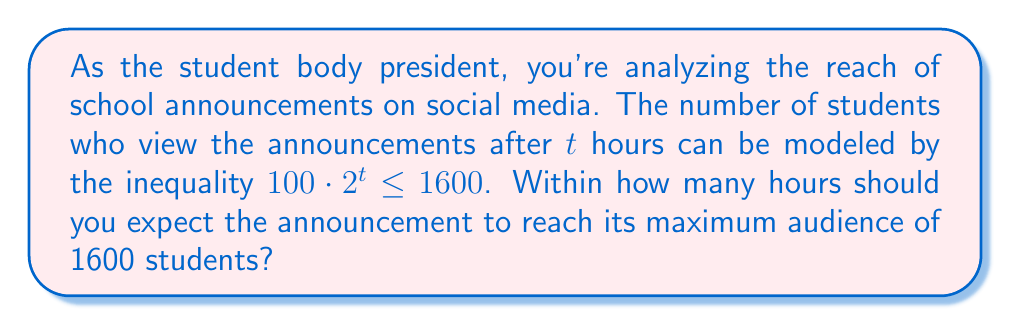Could you help me with this problem? Let's approach this step-by-step:

1) We start with the inequality:
   $100 \cdot 2^t \leq 1600$

2) Divide both sides by 100:
   $2^t \leq 16$

3) To solve for t, we need to take the logarithm (base 2) of both sides:
   $\log_2(2^t) \leq \log_2(16)$

4) The left side simplifies due to the logarithm rule $\log_a(a^x) = x$:
   $t \leq \log_2(16)$

5) We know that $2^4 = 16$, so:
   $t \leq 4$

6) Since t represents time in hours, and we're asked for the number of hours within which the maximum audience is reached, we need the largest integer value of t that satisfies the inequality.

7) The largest integer less than or equal to 4 is 4 itself.

Therefore, you should expect the announcement to reach its maximum audience within 4 hours.
Answer: 4 hours 